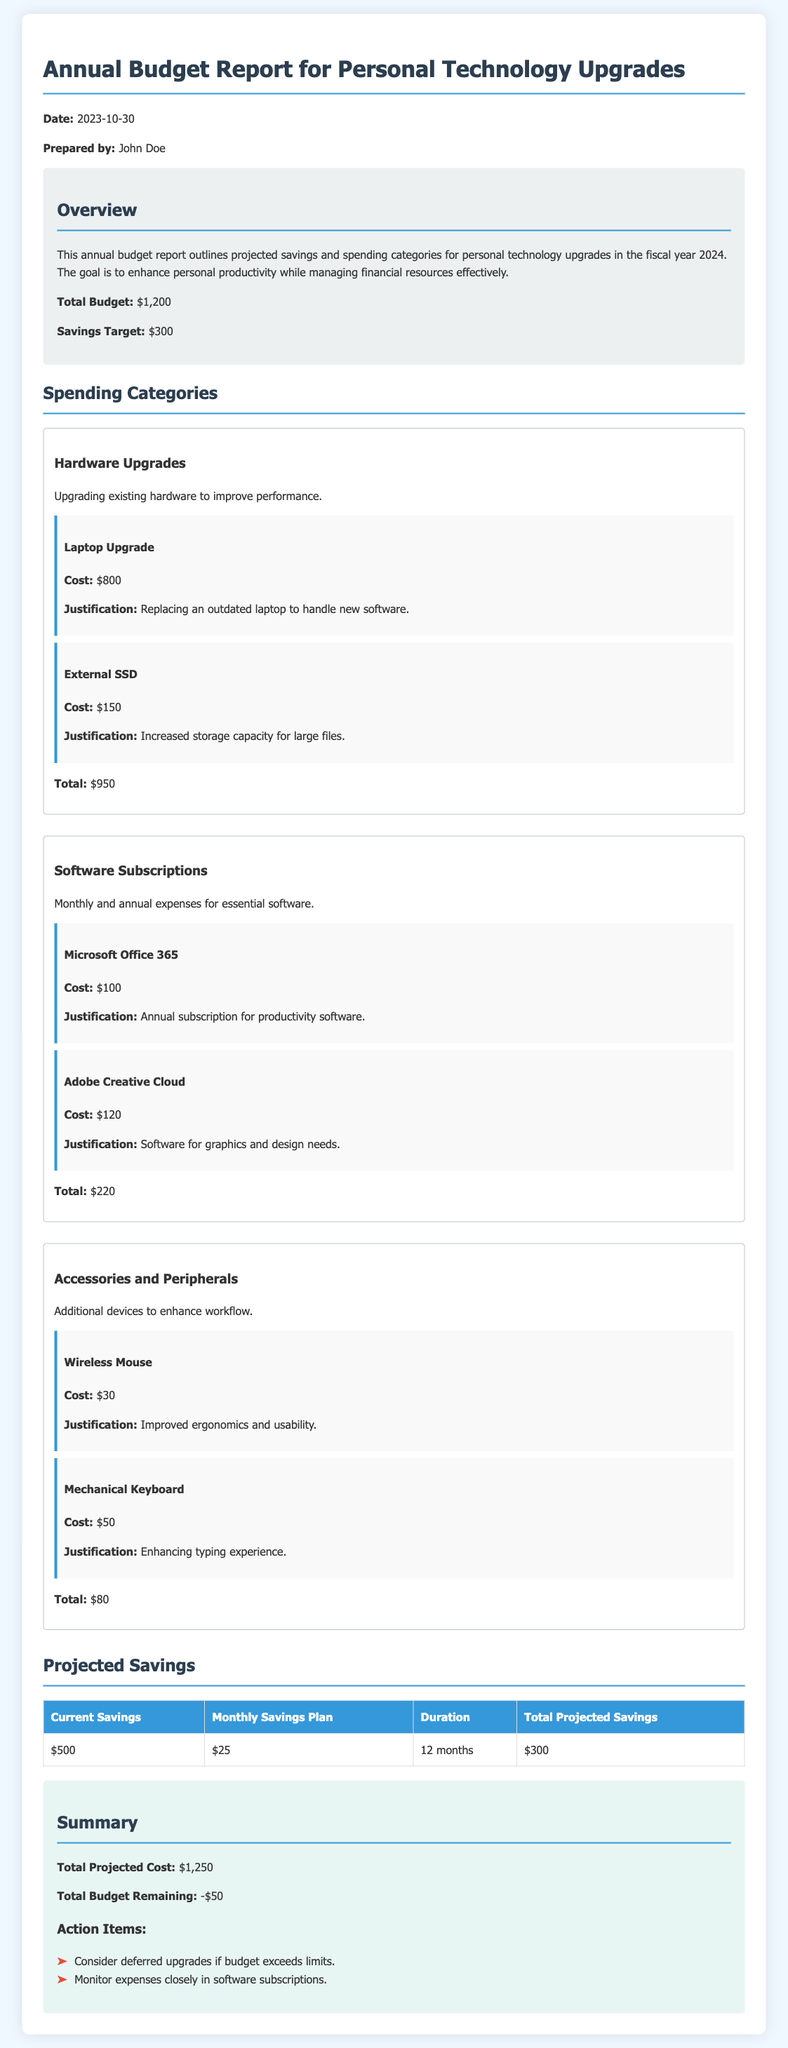What is the total budget? The total budget is explicitly stated in the document as $1,200.
Answer: $1,200 What is the savings target? The savings target is mentioned in the overview, which is $300.
Answer: $300 How much is budgeted for the laptop upgrade? The cost for the laptop upgrade is specified as $800 in the hardware upgrades category.
Answer: $800 What is the total projected cost? The total projected cost is summarized at the end of the document as $1,250.
Answer: $1,250 How much is the current savings? The current savings are listed in the projected savings table as $500.
Answer: $500 What is the total for software subscriptions? The total for software subscriptions is provided in the respective category as $220.
Answer: $220 What is the duration for the monthly savings plan? The duration in the projected savings table is stated to be 12 months.
Answer: 12 months What is the total budget remaining? The total budget remaining is indicated as -$50 in the summary section.
Answer: -$50 What is the justification for the external SSD? The justification for the external SSD is given as "Increased storage capacity for large files."
Answer: Increased storage capacity for large files 